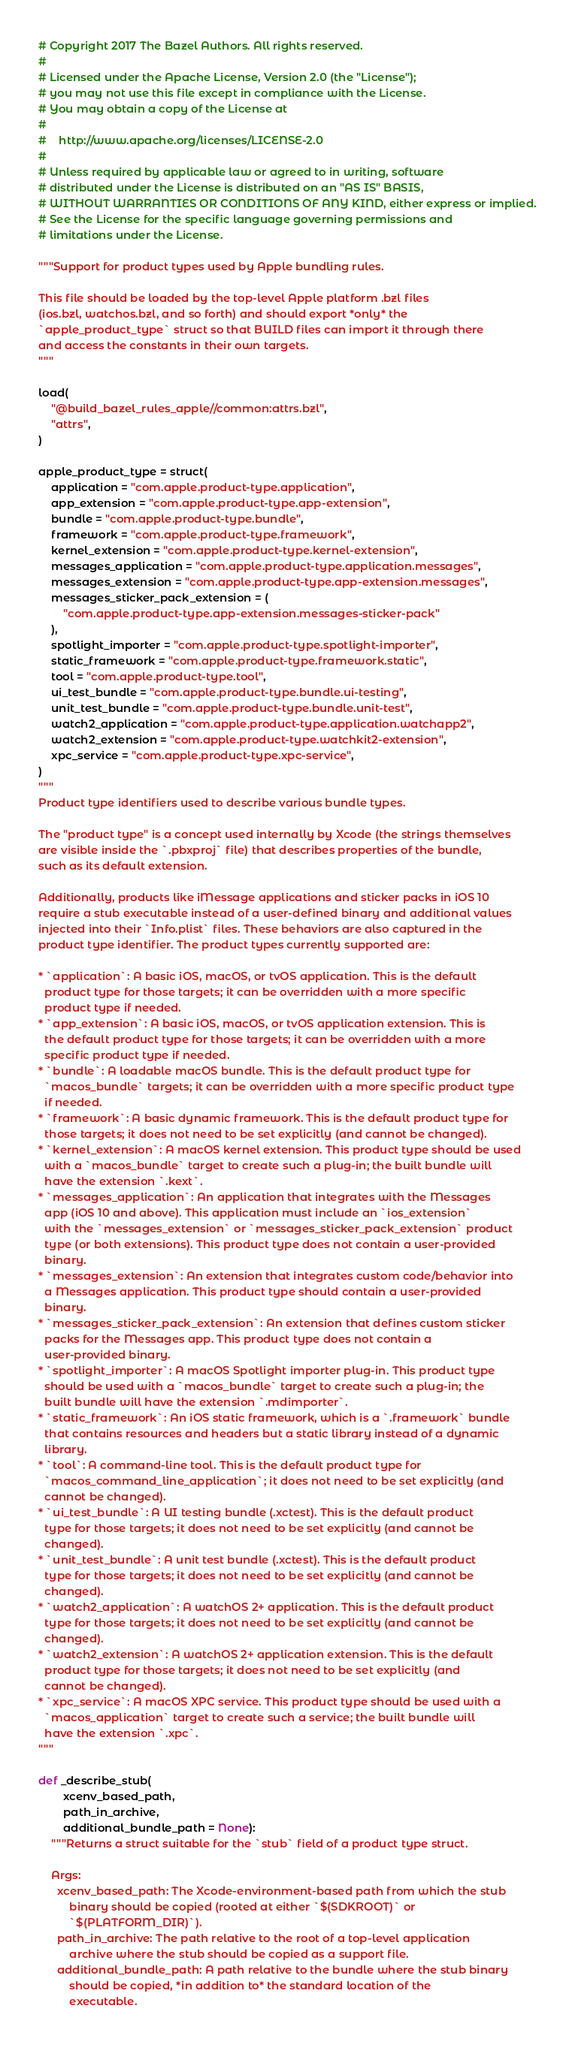<code> <loc_0><loc_0><loc_500><loc_500><_Python_># Copyright 2017 The Bazel Authors. All rights reserved.
#
# Licensed under the Apache License, Version 2.0 (the "License");
# you may not use this file except in compliance with the License.
# You may obtain a copy of the License at
#
#    http://www.apache.org/licenses/LICENSE-2.0
#
# Unless required by applicable law or agreed to in writing, software
# distributed under the License is distributed on an "AS IS" BASIS,
# WITHOUT WARRANTIES OR CONDITIONS OF ANY KIND, either express or implied.
# See the License for the specific language governing permissions and
# limitations under the License.

"""Support for product types used by Apple bundling rules.

This file should be loaded by the top-level Apple platform .bzl files
(ios.bzl, watchos.bzl, and so forth) and should export *only* the
`apple_product_type` struct so that BUILD files can import it through there
and access the constants in their own targets.
"""

load(
    "@build_bazel_rules_apple//common:attrs.bzl",
    "attrs",
)

apple_product_type = struct(
    application = "com.apple.product-type.application",
    app_extension = "com.apple.product-type.app-extension",
    bundle = "com.apple.product-type.bundle",
    framework = "com.apple.product-type.framework",
    kernel_extension = "com.apple.product-type.kernel-extension",
    messages_application = "com.apple.product-type.application.messages",
    messages_extension = "com.apple.product-type.app-extension.messages",
    messages_sticker_pack_extension = (
        "com.apple.product-type.app-extension.messages-sticker-pack"
    ),
    spotlight_importer = "com.apple.product-type.spotlight-importer",
    static_framework = "com.apple.product-type.framework.static",
    tool = "com.apple.product-type.tool",
    ui_test_bundle = "com.apple.product-type.bundle.ui-testing",
    unit_test_bundle = "com.apple.product-type.bundle.unit-test",
    watch2_application = "com.apple.product-type.application.watchapp2",
    watch2_extension = "com.apple.product-type.watchkit2-extension",
    xpc_service = "com.apple.product-type.xpc-service",
)
"""
Product type identifiers used to describe various bundle types.

The "product type" is a concept used internally by Xcode (the strings themselves
are visible inside the `.pbxproj` file) that describes properties of the bundle,
such as its default extension.

Additionally, products like iMessage applications and sticker packs in iOS 10
require a stub executable instead of a user-defined binary and additional values
injected into their `Info.plist` files. These behaviors are also captured in the
product type identifier. The product types currently supported are:

* `application`: A basic iOS, macOS, or tvOS application. This is the default
  product type for those targets; it can be overridden with a more specific
  product type if needed.
* `app_extension`: A basic iOS, macOS, or tvOS application extension. This is
  the default product type for those targets; it can be overridden with a more
  specific product type if needed.
* `bundle`: A loadable macOS bundle. This is the default product type for
  `macos_bundle` targets; it can be overridden with a more specific product type
  if needed.
* `framework`: A basic dynamic framework. This is the default product type for
  those targets; it does not need to be set explicitly (and cannot be changed).
* `kernel_extension`: A macOS kernel extension. This product type should be used
  with a `macos_bundle` target to create such a plug-in; the built bundle will
  have the extension `.kext`.
* `messages_application`: An application that integrates with the Messages
  app (iOS 10 and above). This application must include an `ios_extension`
  with the `messages_extension` or `messages_sticker_pack_extension` product
  type (or both extensions). This product type does not contain a user-provided
  binary.
* `messages_extension`: An extension that integrates custom code/behavior into
  a Messages application. This product type should contain a user-provided
  binary.
* `messages_sticker_pack_extension`: An extension that defines custom sticker
  packs for the Messages app. This product type does not contain a
  user-provided binary.
* `spotlight_importer`: A macOS Spotlight importer plug-in. This product type
  should be used with a `macos_bundle` target to create such a plug-in; the
  built bundle will have the extension `.mdimporter`.
* `static_framework`: An iOS static framework, which is a `.framework` bundle
  that contains resources and headers but a static library instead of a dynamic
  library.
* `tool`: A command-line tool. This is the default product type for
  `macos_command_line_application`; it does not need to be set explicitly (and
  cannot be changed).
* `ui_test_bundle`: A UI testing bundle (.xctest). This is the default product
  type for those targets; it does not need to be set explicitly (and cannot be
  changed).
* `unit_test_bundle`: A unit test bundle (.xctest). This is the default product
  type for those targets; it does not need to be set explicitly (and cannot be
  changed).
* `watch2_application`: A watchOS 2+ application. This is the default product
  type for those targets; it does not need to be set explicitly (and cannot be
  changed).
* `watch2_extension`: A watchOS 2+ application extension. This is the default
  product type for those targets; it does not need to be set explicitly (and
  cannot be changed).
* `xpc_service`: A macOS XPC service. This product type should be used with a
  `macos_application` target to create such a service; the built bundle will
  have the extension `.xpc`.
"""

def _describe_stub(
        xcenv_based_path,
        path_in_archive,
        additional_bundle_path = None):
    """Returns a struct suitable for the `stub` field of a product type struct.

    Args:
      xcenv_based_path: The Xcode-environment-based path from which the stub
          binary should be copied (rooted at either `$(SDKROOT)` or
          `$(PLATFORM_DIR)`).
      path_in_archive: The path relative to the root of a top-level application
          archive where the stub should be copied as a support file.
      additional_bundle_path: A path relative to the bundle where the stub binary
          should be copied, *in addition to* the standard location of the
          executable.
</code> 